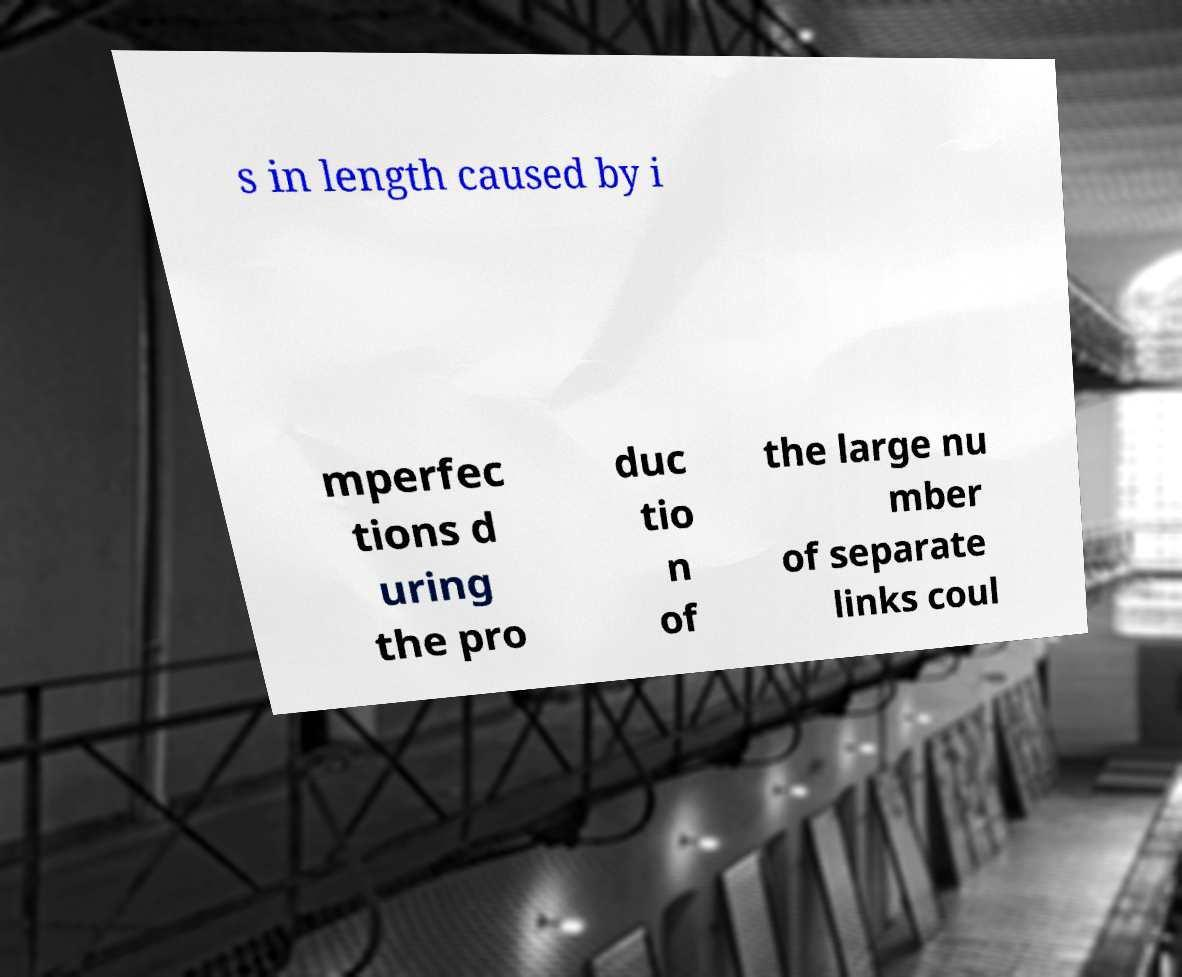Could you extract and type out the text from this image? s in length caused by i mperfec tions d uring the pro duc tio n of the large nu mber of separate links coul 